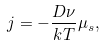<formula> <loc_0><loc_0><loc_500><loc_500>j = - \frac { D \nu } { k T } \mu _ { s } ,</formula> 